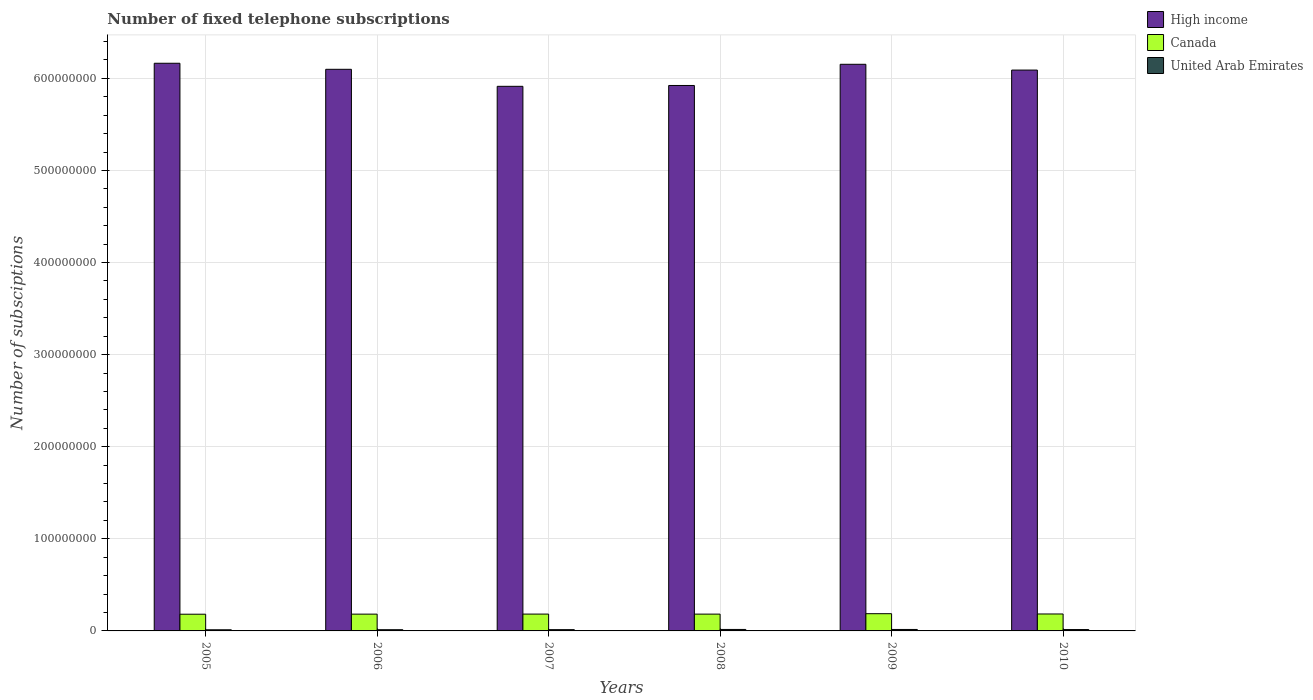How many different coloured bars are there?
Your answer should be very brief. 3. How many groups of bars are there?
Your answer should be compact. 6. Are the number of bars on each tick of the X-axis equal?
Keep it short and to the point. Yes. How many bars are there on the 1st tick from the right?
Provide a succinct answer. 3. What is the label of the 4th group of bars from the left?
Your answer should be very brief. 2008. In how many cases, is the number of bars for a given year not equal to the number of legend labels?
Offer a very short reply. 0. What is the number of fixed telephone subscriptions in High income in 2009?
Offer a very short reply. 6.15e+08. Across all years, what is the maximum number of fixed telephone subscriptions in Canada?
Keep it short and to the point. 1.87e+07. Across all years, what is the minimum number of fixed telephone subscriptions in High income?
Offer a very short reply. 5.91e+08. In which year was the number of fixed telephone subscriptions in United Arab Emirates minimum?
Your answer should be very brief. 2005. What is the total number of fixed telephone subscriptions in High income in the graph?
Keep it short and to the point. 3.63e+09. What is the difference between the number of fixed telephone subscriptions in High income in 2005 and that in 2010?
Your answer should be compact. 7.40e+06. What is the difference between the number of fixed telephone subscriptions in Canada in 2008 and the number of fixed telephone subscriptions in High income in 2006?
Keep it short and to the point. -5.92e+08. What is the average number of fixed telephone subscriptions in United Arab Emirates per year?
Your answer should be very brief. 1.43e+06. In the year 2006, what is the difference between the number of fixed telephone subscriptions in Canada and number of fixed telephone subscriptions in United Arab Emirates?
Offer a very short reply. 1.69e+07. What is the ratio of the number of fixed telephone subscriptions in United Arab Emirates in 2006 to that in 2009?
Make the answer very short. 0.83. Is the difference between the number of fixed telephone subscriptions in Canada in 2005 and 2009 greater than the difference between the number of fixed telephone subscriptions in United Arab Emirates in 2005 and 2009?
Offer a very short reply. No. What is the difference between the highest and the second highest number of fixed telephone subscriptions in United Arab Emirates?
Keep it short and to the point. 1.58e+04. What is the difference between the highest and the lowest number of fixed telephone subscriptions in United Arab Emirates?
Ensure brevity in your answer.  3.59e+05. What does the 1st bar from the right in 2008 represents?
Make the answer very short. United Arab Emirates. Is it the case that in every year, the sum of the number of fixed telephone subscriptions in High income and number of fixed telephone subscriptions in United Arab Emirates is greater than the number of fixed telephone subscriptions in Canada?
Offer a very short reply. Yes. What is the difference between two consecutive major ticks on the Y-axis?
Your response must be concise. 1.00e+08. Does the graph contain grids?
Your answer should be compact. Yes. How are the legend labels stacked?
Your response must be concise. Vertical. What is the title of the graph?
Offer a terse response. Number of fixed telephone subscriptions. What is the label or title of the Y-axis?
Provide a short and direct response. Number of subsciptions. What is the Number of subsciptions in High income in 2005?
Make the answer very short. 6.16e+08. What is the Number of subsciptions of Canada in 2005?
Make the answer very short. 1.81e+07. What is the Number of subsciptions of United Arab Emirates in 2005?
Your answer should be very brief. 1.24e+06. What is the Number of subsciptions of High income in 2006?
Provide a short and direct response. 6.10e+08. What is the Number of subsciptions of Canada in 2006?
Your response must be concise. 1.82e+07. What is the Number of subsciptions of United Arab Emirates in 2006?
Keep it short and to the point. 1.31e+06. What is the Number of subsciptions in High income in 2007?
Provide a short and direct response. 5.91e+08. What is the Number of subsciptions in Canada in 2007?
Provide a succinct answer. 1.83e+07. What is the Number of subsciptions in United Arab Emirates in 2007?
Offer a terse response. 1.39e+06. What is the Number of subsciptions of High income in 2008?
Your answer should be very brief. 5.92e+08. What is the Number of subsciptions of Canada in 2008?
Provide a short and direct response. 1.82e+07. What is the Number of subsciptions of United Arab Emirates in 2008?
Your answer should be compact. 1.60e+06. What is the Number of subsciptions of High income in 2009?
Your answer should be compact. 6.15e+08. What is the Number of subsciptions of Canada in 2009?
Make the answer very short. 1.87e+07. What is the Number of subsciptions of United Arab Emirates in 2009?
Provide a short and direct response. 1.58e+06. What is the Number of subsciptions in High income in 2010?
Keep it short and to the point. 6.09e+08. What is the Number of subsciptions of Canada in 2010?
Keep it short and to the point. 1.84e+07. What is the Number of subsciptions in United Arab Emirates in 2010?
Your answer should be compact. 1.48e+06. Across all years, what is the maximum Number of subsciptions in High income?
Offer a terse response. 6.16e+08. Across all years, what is the maximum Number of subsciptions in Canada?
Ensure brevity in your answer.  1.87e+07. Across all years, what is the maximum Number of subsciptions in United Arab Emirates?
Your answer should be compact. 1.60e+06. Across all years, what is the minimum Number of subsciptions of High income?
Your answer should be compact. 5.91e+08. Across all years, what is the minimum Number of subsciptions in Canada?
Your answer should be compact. 1.81e+07. Across all years, what is the minimum Number of subsciptions in United Arab Emirates?
Give a very brief answer. 1.24e+06. What is the total Number of subsciptions in High income in the graph?
Your answer should be compact. 3.63e+09. What is the total Number of subsciptions of Canada in the graph?
Your answer should be very brief. 1.10e+08. What is the total Number of subsciptions of United Arab Emirates in the graph?
Provide a short and direct response. 8.59e+06. What is the difference between the Number of subsciptions in High income in 2005 and that in 2006?
Your response must be concise. 6.56e+06. What is the difference between the Number of subsciptions of Canada in 2005 and that in 2006?
Offer a terse response. -8.80e+04. What is the difference between the Number of subsciptions of United Arab Emirates in 2005 and that in 2006?
Offer a terse response. -7.28e+04. What is the difference between the Number of subsciptions of High income in 2005 and that in 2007?
Provide a succinct answer. 2.50e+07. What is the difference between the Number of subsciptions in Canada in 2005 and that in 2007?
Give a very brief answer. -1.34e+05. What is the difference between the Number of subsciptions of United Arab Emirates in 2005 and that in 2007?
Make the answer very short. -1.49e+05. What is the difference between the Number of subsciptions in High income in 2005 and that in 2008?
Keep it short and to the point. 2.41e+07. What is the difference between the Number of subsciptions of Canada in 2005 and that in 2008?
Your answer should be very brief. -1.02e+05. What is the difference between the Number of subsciptions of United Arab Emirates in 2005 and that in 2008?
Your response must be concise. -3.59e+05. What is the difference between the Number of subsciptions of High income in 2005 and that in 2009?
Ensure brevity in your answer.  1.12e+06. What is the difference between the Number of subsciptions in Canada in 2005 and that in 2009?
Keep it short and to the point. -5.60e+05. What is the difference between the Number of subsciptions in United Arab Emirates in 2005 and that in 2009?
Offer a very short reply. -3.43e+05. What is the difference between the Number of subsciptions of High income in 2005 and that in 2010?
Make the answer very short. 7.40e+06. What is the difference between the Number of subsciptions of Canada in 2005 and that in 2010?
Provide a succinct answer. -2.46e+05. What is the difference between the Number of subsciptions in United Arab Emirates in 2005 and that in 2010?
Your answer should be compact. -2.43e+05. What is the difference between the Number of subsciptions in High income in 2006 and that in 2007?
Your answer should be very brief. 1.85e+07. What is the difference between the Number of subsciptions in Canada in 2006 and that in 2007?
Your response must be concise. -4.60e+04. What is the difference between the Number of subsciptions of United Arab Emirates in 2006 and that in 2007?
Give a very brief answer. -7.58e+04. What is the difference between the Number of subsciptions of High income in 2006 and that in 2008?
Offer a terse response. 1.76e+07. What is the difference between the Number of subsciptions in Canada in 2006 and that in 2008?
Make the answer very short. -1.40e+04. What is the difference between the Number of subsciptions of United Arab Emirates in 2006 and that in 2008?
Provide a short and direct response. -2.86e+05. What is the difference between the Number of subsciptions of High income in 2006 and that in 2009?
Keep it short and to the point. -5.44e+06. What is the difference between the Number of subsciptions in Canada in 2006 and that in 2009?
Give a very brief answer. -4.72e+05. What is the difference between the Number of subsciptions in United Arab Emirates in 2006 and that in 2009?
Offer a very short reply. -2.70e+05. What is the difference between the Number of subsciptions of High income in 2006 and that in 2010?
Make the answer very short. 8.41e+05. What is the difference between the Number of subsciptions in Canada in 2006 and that in 2010?
Keep it short and to the point. -1.58e+05. What is the difference between the Number of subsciptions in United Arab Emirates in 2006 and that in 2010?
Make the answer very short. -1.70e+05. What is the difference between the Number of subsciptions of High income in 2007 and that in 2008?
Your answer should be very brief. -9.27e+05. What is the difference between the Number of subsciptions of Canada in 2007 and that in 2008?
Give a very brief answer. 3.20e+04. What is the difference between the Number of subsciptions in United Arab Emirates in 2007 and that in 2008?
Keep it short and to the point. -2.10e+05. What is the difference between the Number of subsciptions of High income in 2007 and that in 2009?
Your answer should be very brief. -2.39e+07. What is the difference between the Number of subsciptions of Canada in 2007 and that in 2009?
Provide a short and direct response. -4.26e+05. What is the difference between the Number of subsciptions of United Arab Emirates in 2007 and that in 2009?
Keep it short and to the point. -1.95e+05. What is the difference between the Number of subsciptions in High income in 2007 and that in 2010?
Ensure brevity in your answer.  -1.76e+07. What is the difference between the Number of subsciptions in Canada in 2007 and that in 2010?
Make the answer very short. -1.12e+05. What is the difference between the Number of subsciptions of United Arab Emirates in 2007 and that in 2010?
Ensure brevity in your answer.  -9.40e+04. What is the difference between the Number of subsciptions of High income in 2008 and that in 2009?
Offer a terse response. -2.30e+07. What is the difference between the Number of subsciptions of Canada in 2008 and that in 2009?
Offer a terse response. -4.58e+05. What is the difference between the Number of subsciptions of United Arab Emirates in 2008 and that in 2009?
Your response must be concise. 1.58e+04. What is the difference between the Number of subsciptions of High income in 2008 and that in 2010?
Ensure brevity in your answer.  -1.67e+07. What is the difference between the Number of subsciptions in Canada in 2008 and that in 2010?
Give a very brief answer. -1.44e+05. What is the difference between the Number of subsciptions in United Arab Emirates in 2008 and that in 2010?
Offer a terse response. 1.17e+05. What is the difference between the Number of subsciptions in High income in 2009 and that in 2010?
Make the answer very short. 6.28e+06. What is the difference between the Number of subsciptions in Canada in 2009 and that in 2010?
Provide a succinct answer. 3.14e+05. What is the difference between the Number of subsciptions in United Arab Emirates in 2009 and that in 2010?
Ensure brevity in your answer.  1.01e+05. What is the difference between the Number of subsciptions of High income in 2005 and the Number of subsciptions of Canada in 2006?
Provide a succinct answer. 5.98e+08. What is the difference between the Number of subsciptions of High income in 2005 and the Number of subsciptions of United Arab Emirates in 2006?
Offer a very short reply. 6.15e+08. What is the difference between the Number of subsciptions in Canada in 2005 and the Number of subsciptions in United Arab Emirates in 2006?
Keep it short and to the point. 1.68e+07. What is the difference between the Number of subsciptions of High income in 2005 and the Number of subsciptions of Canada in 2007?
Keep it short and to the point. 5.98e+08. What is the difference between the Number of subsciptions of High income in 2005 and the Number of subsciptions of United Arab Emirates in 2007?
Provide a succinct answer. 6.15e+08. What is the difference between the Number of subsciptions of Canada in 2005 and the Number of subsciptions of United Arab Emirates in 2007?
Your answer should be compact. 1.68e+07. What is the difference between the Number of subsciptions in High income in 2005 and the Number of subsciptions in Canada in 2008?
Your response must be concise. 5.98e+08. What is the difference between the Number of subsciptions of High income in 2005 and the Number of subsciptions of United Arab Emirates in 2008?
Ensure brevity in your answer.  6.15e+08. What is the difference between the Number of subsciptions in Canada in 2005 and the Number of subsciptions in United Arab Emirates in 2008?
Make the answer very short. 1.66e+07. What is the difference between the Number of subsciptions of High income in 2005 and the Number of subsciptions of Canada in 2009?
Make the answer very short. 5.98e+08. What is the difference between the Number of subsciptions in High income in 2005 and the Number of subsciptions in United Arab Emirates in 2009?
Your answer should be very brief. 6.15e+08. What is the difference between the Number of subsciptions of Canada in 2005 and the Number of subsciptions of United Arab Emirates in 2009?
Offer a terse response. 1.66e+07. What is the difference between the Number of subsciptions of High income in 2005 and the Number of subsciptions of Canada in 2010?
Offer a very short reply. 5.98e+08. What is the difference between the Number of subsciptions in High income in 2005 and the Number of subsciptions in United Arab Emirates in 2010?
Your answer should be very brief. 6.15e+08. What is the difference between the Number of subsciptions in Canada in 2005 and the Number of subsciptions in United Arab Emirates in 2010?
Keep it short and to the point. 1.67e+07. What is the difference between the Number of subsciptions in High income in 2006 and the Number of subsciptions in Canada in 2007?
Give a very brief answer. 5.92e+08. What is the difference between the Number of subsciptions of High income in 2006 and the Number of subsciptions of United Arab Emirates in 2007?
Keep it short and to the point. 6.08e+08. What is the difference between the Number of subsciptions of Canada in 2006 and the Number of subsciptions of United Arab Emirates in 2007?
Offer a terse response. 1.69e+07. What is the difference between the Number of subsciptions of High income in 2006 and the Number of subsciptions of Canada in 2008?
Ensure brevity in your answer.  5.92e+08. What is the difference between the Number of subsciptions in High income in 2006 and the Number of subsciptions in United Arab Emirates in 2008?
Your answer should be compact. 6.08e+08. What is the difference between the Number of subsciptions of Canada in 2006 and the Number of subsciptions of United Arab Emirates in 2008?
Offer a terse response. 1.66e+07. What is the difference between the Number of subsciptions in High income in 2006 and the Number of subsciptions in Canada in 2009?
Offer a terse response. 5.91e+08. What is the difference between the Number of subsciptions in High income in 2006 and the Number of subsciptions in United Arab Emirates in 2009?
Provide a short and direct response. 6.08e+08. What is the difference between the Number of subsciptions of Canada in 2006 and the Number of subsciptions of United Arab Emirates in 2009?
Offer a very short reply. 1.67e+07. What is the difference between the Number of subsciptions in High income in 2006 and the Number of subsciptions in Canada in 2010?
Offer a very short reply. 5.91e+08. What is the difference between the Number of subsciptions in High income in 2006 and the Number of subsciptions in United Arab Emirates in 2010?
Offer a terse response. 6.08e+08. What is the difference between the Number of subsciptions in Canada in 2006 and the Number of subsciptions in United Arab Emirates in 2010?
Offer a terse response. 1.68e+07. What is the difference between the Number of subsciptions in High income in 2007 and the Number of subsciptions in Canada in 2008?
Your answer should be compact. 5.73e+08. What is the difference between the Number of subsciptions in High income in 2007 and the Number of subsciptions in United Arab Emirates in 2008?
Offer a terse response. 5.90e+08. What is the difference between the Number of subsciptions of Canada in 2007 and the Number of subsciptions of United Arab Emirates in 2008?
Keep it short and to the point. 1.67e+07. What is the difference between the Number of subsciptions of High income in 2007 and the Number of subsciptions of Canada in 2009?
Provide a succinct answer. 5.73e+08. What is the difference between the Number of subsciptions in High income in 2007 and the Number of subsciptions in United Arab Emirates in 2009?
Provide a short and direct response. 5.90e+08. What is the difference between the Number of subsciptions in Canada in 2007 and the Number of subsciptions in United Arab Emirates in 2009?
Provide a succinct answer. 1.67e+07. What is the difference between the Number of subsciptions of High income in 2007 and the Number of subsciptions of Canada in 2010?
Make the answer very short. 5.73e+08. What is the difference between the Number of subsciptions in High income in 2007 and the Number of subsciptions in United Arab Emirates in 2010?
Offer a very short reply. 5.90e+08. What is the difference between the Number of subsciptions in Canada in 2007 and the Number of subsciptions in United Arab Emirates in 2010?
Make the answer very short. 1.68e+07. What is the difference between the Number of subsciptions of High income in 2008 and the Number of subsciptions of Canada in 2009?
Your response must be concise. 5.74e+08. What is the difference between the Number of subsciptions in High income in 2008 and the Number of subsciptions in United Arab Emirates in 2009?
Ensure brevity in your answer.  5.91e+08. What is the difference between the Number of subsciptions of Canada in 2008 and the Number of subsciptions of United Arab Emirates in 2009?
Make the answer very short. 1.67e+07. What is the difference between the Number of subsciptions of High income in 2008 and the Number of subsciptions of Canada in 2010?
Your response must be concise. 5.74e+08. What is the difference between the Number of subsciptions in High income in 2008 and the Number of subsciptions in United Arab Emirates in 2010?
Provide a succinct answer. 5.91e+08. What is the difference between the Number of subsciptions of Canada in 2008 and the Number of subsciptions of United Arab Emirates in 2010?
Your answer should be compact. 1.68e+07. What is the difference between the Number of subsciptions of High income in 2009 and the Number of subsciptions of Canada in 2010?
Provide a short and direct response. 5.97e+08. What is the difference between the Number of subsciptions of High income in 2009 and the Number of subsciptions of United Arab Emirates in 2010?
Offer a terse response. 6.14e+08. What is the difference between the Number of subsciptions of Canada in 2009 and the Number of subsciptions of United Arab Emirates in 2010?
Provide a succinct answer. 1.72e+07. What is the average Number of subsciptions of High income per year?
Your answer should be very brief. 6.06e+08. What is the average Number of subsciptions of Canada per year?
Ensure brevity in your answer.  1.83e+07. What is the average Number of subsciptions in United Arab Emirates per year?
Give a very brief answer. 1.43e+06. In the year 2005, what is the difference between the Number of subsciptions of High income and Number of subsciptions of Canada?
Your response must be concise. 5.98e+08. In the year 2005, what is the difference between the Number of subsciptions of High income and Number of subsciptions of United Arab Emirates?
Offer a terse response. 6.15e+08. In the year 2005, what is the difference between the Number of subsciptions of Canada and Number of subsciptions of United Arab Emirates?
Provide a short and direct response. 1.69e+07. In the year 2006, what is the difference between the Number of subsciptions of High income and Number of subsciptions of Canada?
Ensure brevity in your answer.  5.92e+08. In the year 2006, what is the difference between the Number of subsciptions of High income and Number of subsciptions of United Arab Emirates?
Your response must be concise. 6.08e+08. In the year 2006, what is the difference between the Number of subsciptions in Canada and Number of subsciptions in United Arab Emirates?
Offer a terse response. 1.69e+07. In the year 2007, what is the difference between the Number of subsciptions in High income and Number of subsciptions in Canada?
Make the answer very short. 5.73e+08. In the year 2007, what is the difference between the Number of subsciptions of High income and Number of subsciptions of United Arab Emirates?
Your answer should be compact. 5.90e+08. In the year 2007, what is the difference between the Number of subsciptions of Canada and Number of subsciptions of United Arab Emirates?
Offer a terse response. 1.69e+07. In the year 2008, what is the difference between the Number of subsciptions in High income and Number of subsciptions in Canada?
Your answer should be compact. 5.74e+08. In the year 2008, what is the difference between the Number of subsciptions in High income and Number of subsciptions in United Arab Emirates?
Ensure brevity in your answer.  5.91e+08. In the year 2008, what is the difference between the Number of subsciptions of Canada and Number of subsciptions of United Arab Emirates?
Your response must be concise. 1.67e+07. In the year 2009, what is the difference between the Number of subsciptions in High income and Number of subsciptions in Canada?
Provide a succinct answer. 5.97e+08. In the year 2009, what is the difference between the Number of subsciptions in High income and Number of subsciptions in United Arab Emirates?
Make the answer very short. 6.14e+08. In the year 2009, what is the difference between the Number of subsciptions in Canada and Number of subsciptions in United Arab Emirates?
Keep it short and to the point. 1.71e+07. In the year 2010, what is the difference between the Number of subsciptions in High income and Number of subsciptions in Canada?
Ensure brevity in your answer.  5.91e+08. In the year 2010, what is the difference between the Number of subsciptions of High income and Number of subsciptions of United Arab Emirates?
Your answer should be very brief. 6.07e+08. In the year 2010, what is the difference between the Number of subsciptions of Canada and Number of subsciptions of United Arab Emirates?
Provide a short and direct response. 1.69e+07. What is the ratio of the Number of subsciptions in High income in 2005 to that in 2006?
Keep it short and to the point. 1.01. What is the ratio of the Number of subsciptions of Canada in 2005 to that in 2006?
Make the answer very short. 1. What is the ratio of the Number of subsciptions in United Arab Emirates in 2005 to that in 2006?
Provide a succinct answer. 0.94. What is the ratio of the Number of subsciptions of High income in 2005 to that in 2007?
Ensure brevity in your answer.  1.04. What is the ratio of the Number of subsciptions of Canada in 2005 to that in 2007?
Your answer should be very brief. 0.99. What is the ratio of the Number of subsciptions of United Arab Emirates in 2005 to that in 2007?
Make the answer very short. 0.89. What is the ratio of the Number of subsciptions of High income in 2005 to that in 2008?
Provide a succinct answer. 1.04. What is the ratio of the Number of subsciptions in United Arab Emirates in 2005 to that in 2008?
Provide a succinct answer. 0.78. What is the ratio of the Number of subsciptions in High income in 2005 to that in 2009?
Provide a succinct answer. 1. What is the ratio of the Number of subsciptions of Canada in 2005 to that in 2009?
Offer a terse response. 0.97. What is the ratio of the Number of subsciptions in United Arab Emirates in 2005 to that in 2009?
Your response must be concise. 0.78. What is the ratio of the Number of subsciptions in High income in 2005 to that in 2010?
Keep it short and to the point. 1.01. What is the ratio of the Number of subsciptions of Canada in 2005 to that in 2010?
Keep it short and to the point. 0.99. What is the ratio of the Number of subsciptions of United Arab Emirates in 2005 to that in 2010?
Your response must be concise. 0.84. What is the ratio of the Number of subsciptions of High income in 2006 to that in 2007?
Your answer should be very brief. 1.03. What is the ratio of the Number of subsciptions in United Arab Emirates in 2006 to that in 2007?
Ensure brevity in your answer.  0.95. What is the ratio of the Number of subsciptions in High income in 2006 to that in 2008?
Provide a short and direct response. 1.03. What is the ratio of the Number of subsciptions in United Arab Emirates in 2006 to that in 2008?
Offer a terse response. 0.82. What is the ratio of the Number of subsciptions of Canada in 2006 to that in 2009?
Make the answer very short. 0.97. What is the ratio of the Number of subsciptions in United Arab Emirates in 2006 to that in 2009?
Give a very brief answer. 0.83. What is the ratio of the Number of subsciptions in High income in 2006 to that in 2010?
Your answer should be very brief. 1. What is the ratio of the Number of subsciptions of United Arab Emirates in 2006 to that in 2010?
Keep it short and to the point. 0.89. What is the ratio of the Number of subsciptions of Canada in 2007 to that in 2008?
Your response must be concise. 1. What is the ratio of the Number of subsciptions in United Arab Emirates in 2007 to that in 2008?
Your response must be concise. 0.87. What is the ratio of the Number of subsciptions of High income in 2007 to that in 2009?
Your answer should be compact. 0.96. What is the ratio of the Number of subsciptions in Canada in 2007 to that in 2009?
Your answer should be very brief. 0.98. What is the ratio of the Number of subsciptions of United Arab Emirates in 2007 to that in 2009?
Your answer should be very brief. 0.88. What is the ratio of the Number of subsciptions in Canada in 2007 to that in 2010?
Provide a short and direct response. 0.99. What is the ratio of the Number of subsciptions in United Arab Emirates in 2007 to that in 2010?
Ensure brevity in your answer.  0.94. What is the ratio of the Number of subsciptions of High income in 2008 to that in 2009?
Keep it short and to the point. 0.96. What is the ratio of the Number of subsciptions of Canada in 2008 to that in 2009?
Provide a succinct answer. 0.98. What is the ratio of the Number of subsciptions of High income in 2008 to that in 2010?
Offer a very short reply. 0.97. What is the ratio of the Number of subsciptions of Canada in 2008 to that in 2010?
Give a very brief answer. 0.99. What is the ratio of the Number of subsciptions of United Arab Emirates in 2008 to that in 2010?
Your answer should be compact. 1.08. What is the ratio of the Number of subsciptions in High income in 2009 to that in 2010?
Offer a terse response. 1.01. What is the ratio of the Number of subsciptions in Canada in 2009 to that in 2010?
Provide a short and direct response. 1.02. What is the ratio of the Number of subsciptions of United Arab Emirates in 2009 to that in 2010?
Provide a short and direct response. 1.07. What is the difference between the highest and the second highest Number of subsciptions in High income?
Make the answer very short. 1.12e+06. What is the difference between the highest and the second highest Number of subsciptions of Canada?
Offer a terse response. 3.14e+05. What is the difference between the highest and the second highest Number of subsciptions in United Arab Emirates?
Provide a succinct answer. 1.58e+04. What is the difference between the highest and the lowest Number of subsciptions of High income?
Make the answer very short. 2.50e+07. What is the difference between the highest and the lowest Number of subsciptions in Canada?
Provide a succinct answer. 5.60e+05. What is the difference between the highest and the lowest Number of subsciptions of United Arab Emirates?
Ensure brevity in your answer.  3.59e+05. 